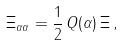<formula> <loc_0><loc_0><loc_500><loc_500>\Xi _ { \alpha \alpha } = \frac { 1 } { 2 } \, Q ( \alpha ) \, \Xi \, ,</formula> 